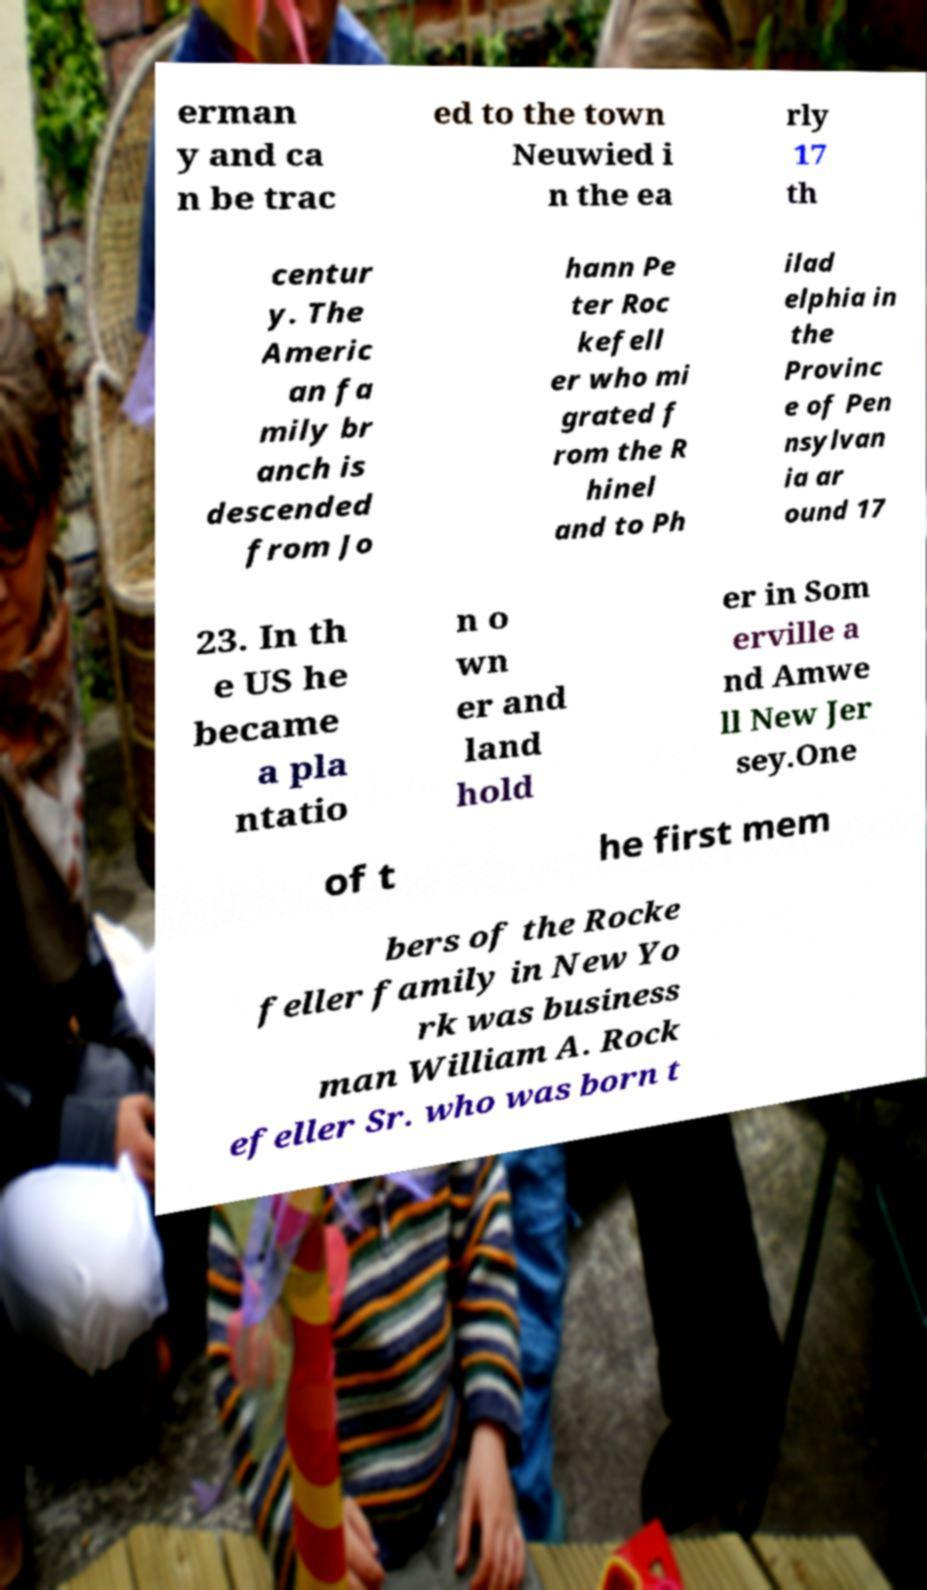I need the written content from this picture converted into text. Can you do that? erman y and ca n be trac ed to the town Neuwied i n the ea rly 17 th centur y. The Americ an fa mily br anch is descended from Jo hann Pe ter Roc kefell er who mi grated f rom the R hinel and to Ph ilad elphia in the Provinc e of Pen nsylvan ia ar ound 17 23. In th e US he became a pla ntatio n o wn er and land hold er in Som erville a nd Amwe ll New Jer sey.One of t he first mem bers of the Rocke feller family in New Yo rk was business man William A. Rock efeller Sr. who was born t 